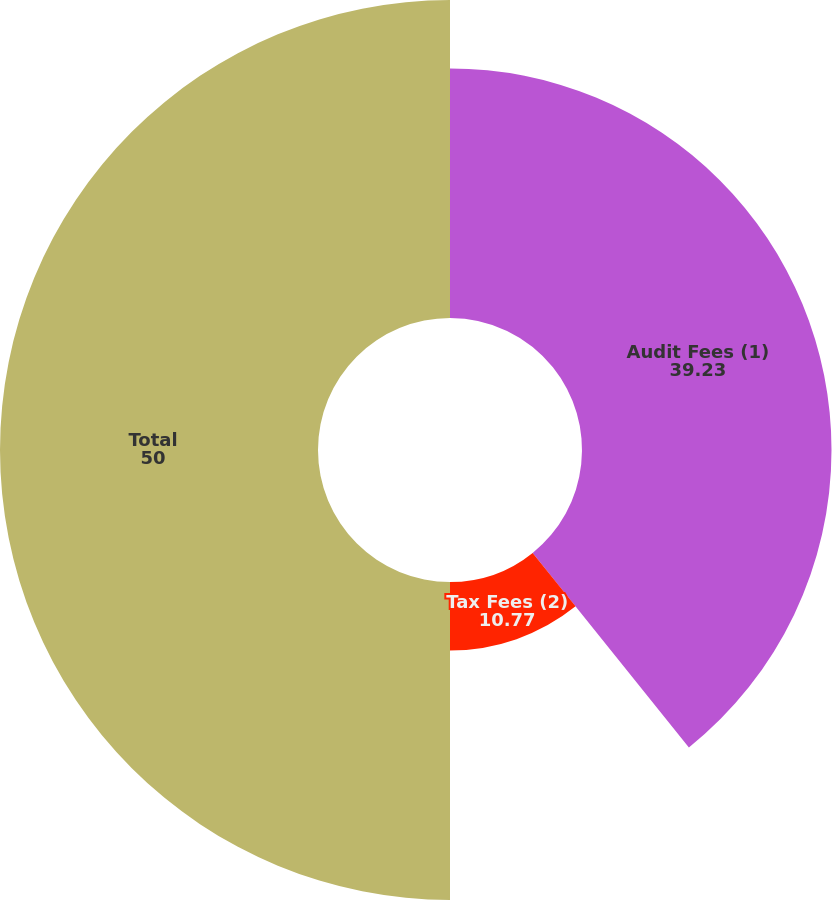<chart> <loc_0><loc_0><loc_500><loc_500><pie_chart><fcel>Audit Fees (1)<fcel>Tax Fees (2)<fcel>Total<nl><fcel>39.23%<fcel>10.77%<fcel>50.0%<nl></chart> 